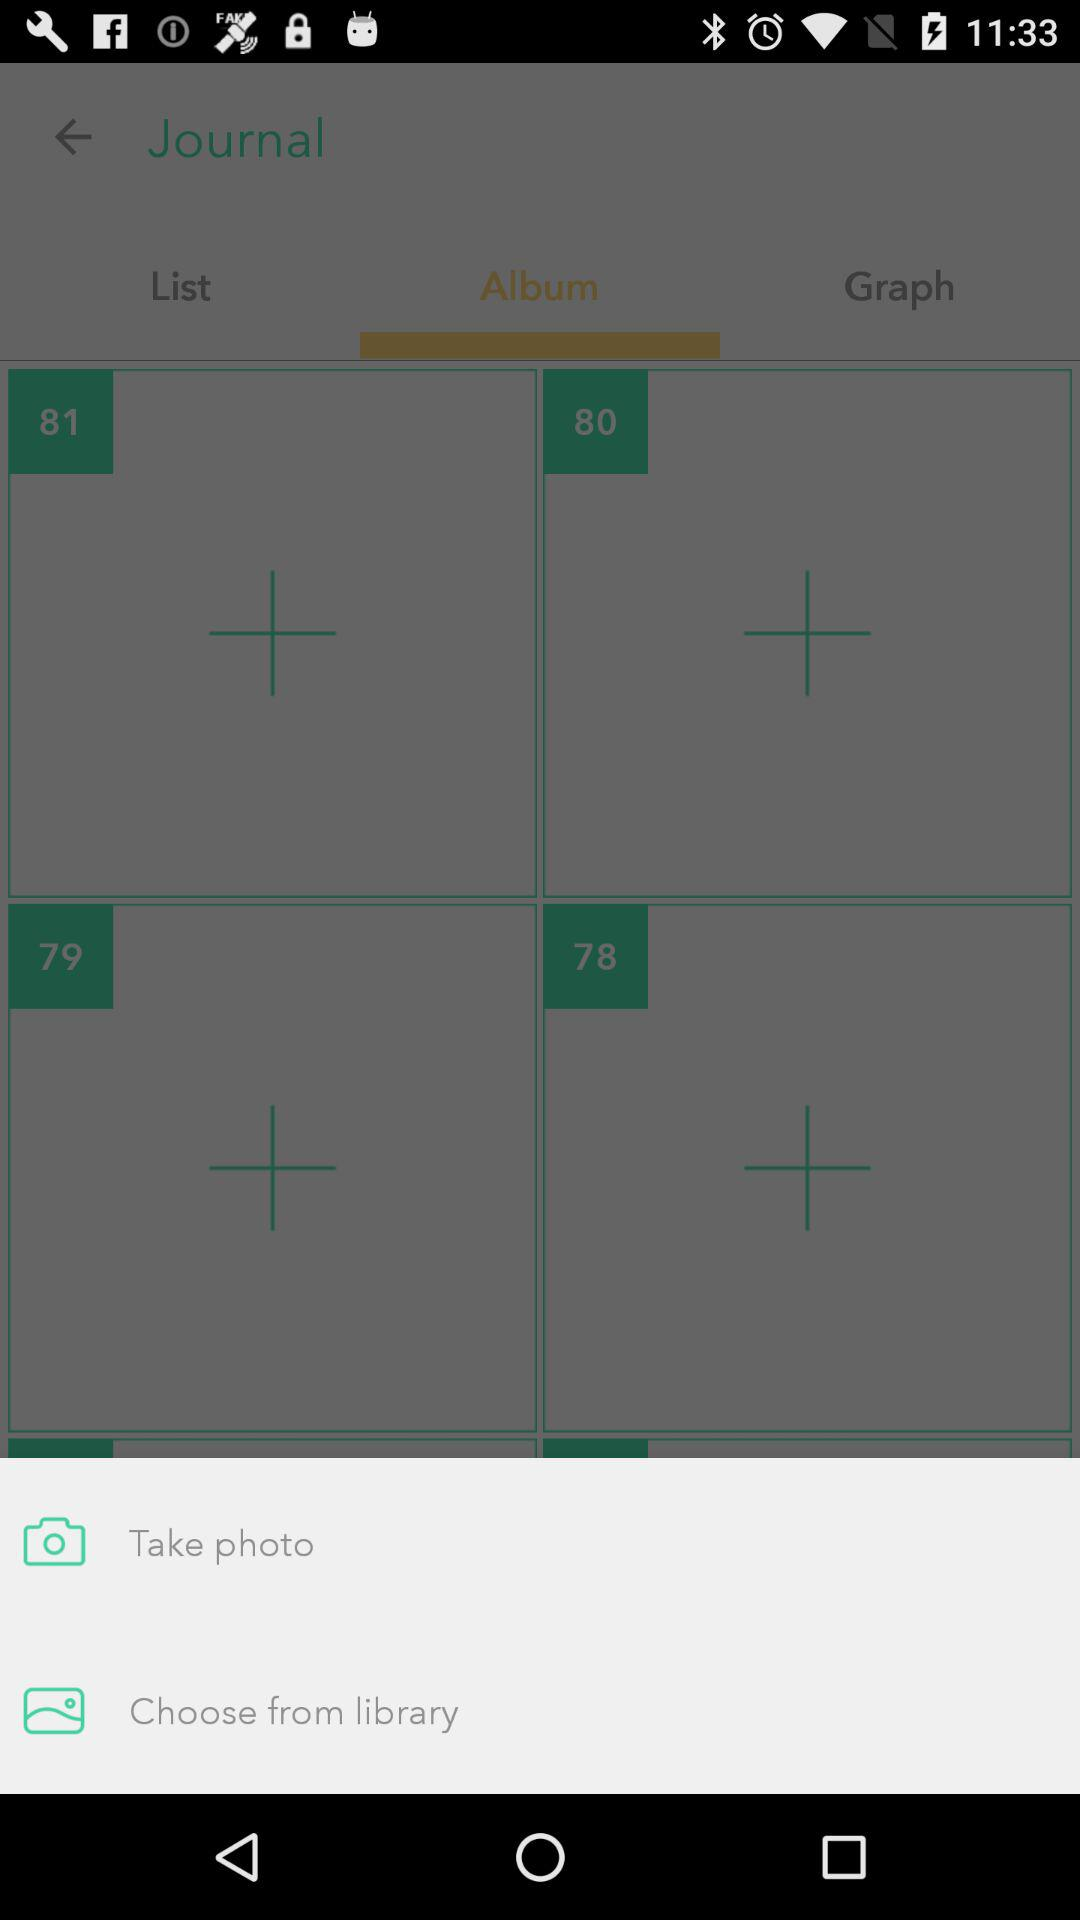What are the different available options for uploading the picture to the album? The different available options for uploading the picture to the album are "Take photo" and "Choose from library". 